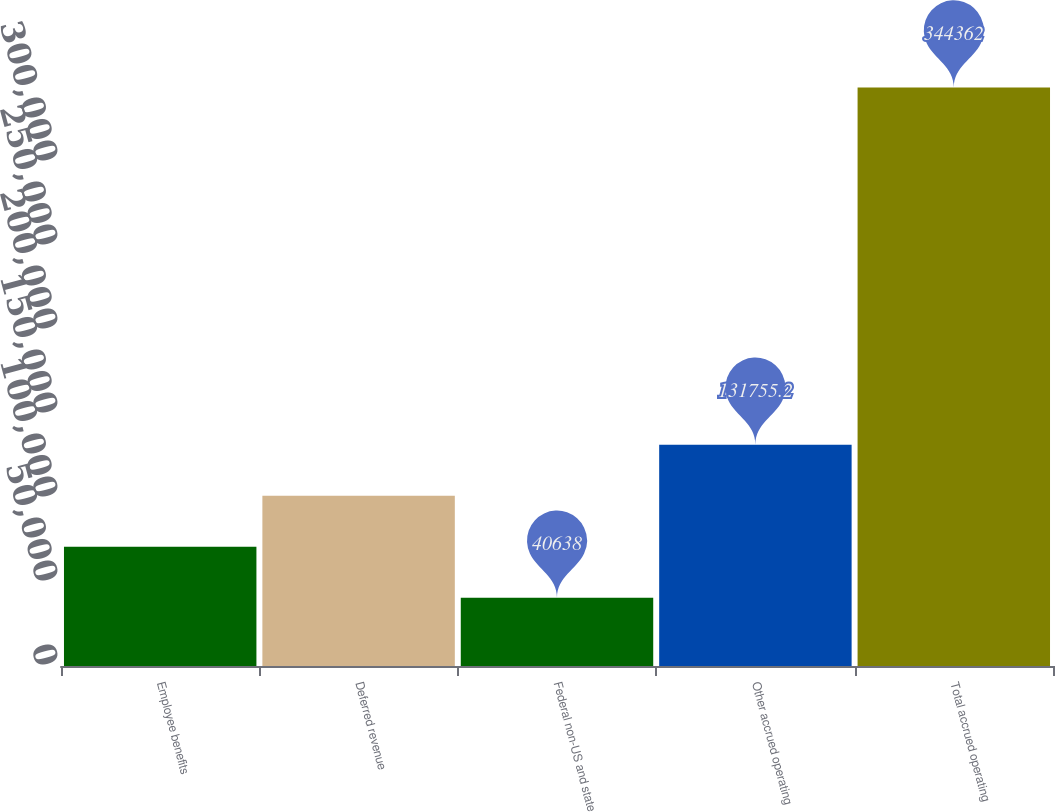<chart> <loc_0><loc_0><loc_500><loc_500><bar_chart><fcel>Employee benefits<fcel>Deferred revenue<fcel>Federal non-US and state<fcel>Other accrued operating<fcel>Total accrued operating<nl><fcel>71010.4<fcel>101383<fcel>40638<fcel>131755<fcel>344362<nl></chart> 